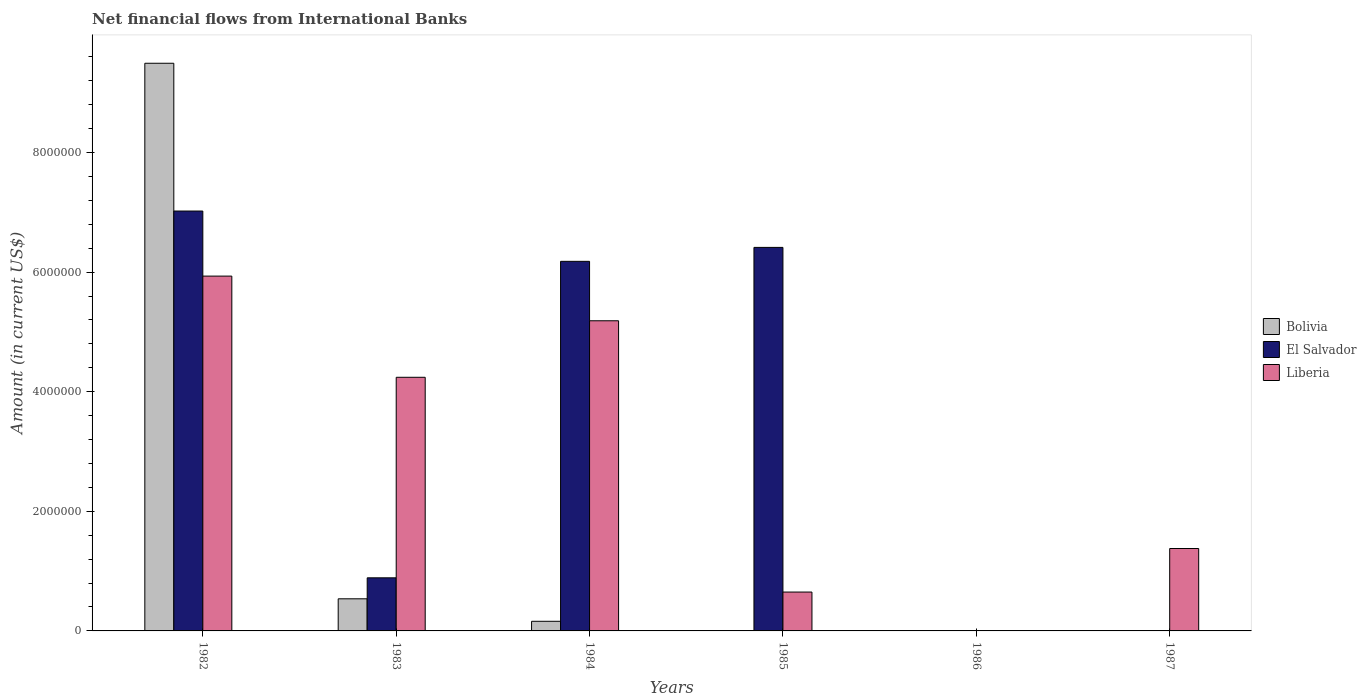How many different coloured bars are there?
Offer a terse response. 3. How many bars are there on the 3rd tick from the right?
Keep it short and to the point. 2. What is the label of the 5th group of bars from the left?
Keep it short and to the point. 1986. In how many cases, is the number of bars for a given year not equal to the number of legend labels?
Your answer should be compact. 3. What is the net financial aid flows in Bolivia in 1987?
Offer a terse response. 0. Across all years, what is the maximum net financial aid flows in El Salvador?
Your answer should be very brief. 7.02e+06. In which year was the net financial aid flows in El Salvador maximum?
Make the answer very short. 1982. What is the total net financial aid flows in Liberia in the graph?
Ensure brevity in your answer.  1.74e+07. What is the difference between the net financial aid flows in Bolivia in 1982 and that in 1983?
Offer a terse response. 8.96e+06. What is the difference between the net financial aid flows in Liberia in 1986 and the net financial aid flows in Bolivia in 1983?
Offer a very short reply. -5.37e+05. What is the average net financial aid flows in Bolivia per year?
Provide a succinct answer. 1.70e+06. In the year 1982, what is the difference between the net financial aid flows in El Salvador and net financial aid flows in Liberia?
Provide a succinct answer. 1.09e+06. What is the ratio of the net financial aid flows in Liberia in 1982 to that in 1985?
Ensure brevity in your answer.  9.13. Is the net financial aid flows in El Salvador in 1984 less than that in 1985?
Provide a succinct answer. Yes. Is the difference between the net financial aid flows in El Salvador in 1983 and 1985 greater than the difference between the net financial aid flows in Liberia in 1983 and 1985?
Provide a succinct answer. No. What is the difference between the highest and the second highest net financial aid flows in Liberia?
Provide a succinct answer. 7.47e+05. What is the difference between the highest and the lowest net financial aid flows in Bolivia?
Ensure brevity in your answer.  9.49e+06. In how many years, is the net financial aid flows in Bolivia greater than the average net financial aid flows in Bolivia taken over all years?
Provide a short and direct response. 1. Is the sum of the net financial aid flows in Bolivia in 1982 and 1984 greater than the maximum net financial aid flows in El Salvador across all years?
Keep it short and to the point. Yes. Is it the case that in every year, the sum of the net financial aid flows in Bolivia and net financial aid flows in Liberia is greater than the net financial aid flows in El Salvador?
Make the answer very short. No. Are all the bars in the graph horizontal?
Provide a short and direct response. No. Are the values on the major ticks of Y-axis written in scientific E-notation?
Keep it short and to the point. No. Does the graph contain any zero values?
Your answer should be very brief. Yes. Where does the legend appear in the graph?
Keep it short and to the point. Center right. How many legend labels are there?
Provide a short and direct response. 3. What is the title of the graph?
Make the answer very short. Net financial flows from International Banks. What is the label or title of the X-axis?
Your answer should be very brief. Years. What is the Amount (in current US$) in Bolivia in 1982?
Your answer should be very brief. 9.49e+06. What is the Amount (in current US$) of El Salvador in 1982?
Keep it short and to the point. 7.02e+06. What is the Amount (in current US$) of Liberia in 1982?
Keep it short and to the point. 5.93e+06. What is the Amount (in current US$) of Bolivia in 1983?
Your answer should be very brief. 5.37e+05. What is the Amount (in current US$) in El Salvador in 1983?
Keep it short and to the point. 8.88e+05. What is the Amount (in current US$) of Liberia in 1983?
Keep it short and to the point. 4.24e+06. What is the Amount (in current US$) in Bolivia in 1984?
Your answer should be very brief. 1.61e+05. What is the Amount (in current US$) of El Salvador in 1984?
Keep it short and to the point. 6.18e+06. What is the Amount (in current US$) of Liberia in 1984?
Give a very brief answer. 5.19e+06. What is the Amount (in current US$) of El Salvador in 1985?
Provide a short and direct response. 6.41e+06. What is the Amount (in current US$) in Liberia in 1985?
Ensure brevity in your answer.  6.50e+05. What is the Amount (in current US$) of Liberia in 1986?
Provide a succinct answer. 0. What is the Amount (in current US$) in Liberia in 1987?
Make the answer very short. 1.38e+06. Across all years, what is the maximum Amount (in current US$) in Bolivia?
Give a very brief answer. 9.49e+06. Across all years, what is the maximum Amount (in current US$) of El Salvador?
Make the answer very short. 7.02e+06. Across all years, what is the maximum Amount (in current US$) in Liberia?
Keep it short and to the point. 5.93e+06. What is the total Amount (in current US$) of Bolivia in the graph?
Keep it short and to the point. 1.02e+07. What is the total Amount (in current US$) in El Salvador in the graph?
Make the answer very short. 2.05e+07. What is the total Amount (in current US$) in Liberia in the graph?
Make the answer very short. 1.74e+07. What is the difference between the Amount (in current US$) of Bolivia in 1982 and that in 1983?
Your answer should be very brief. 8.96e+06. What is the difference between the Amount (in current US$) of El Salvador in 1982 and that in 1983?
Offer a very short reply. 6.13e+06. What is the difference between the Amount (in current US$) in Liberia in 1982 and that in 1983?
Ensure brevity in your answer.  1.69e+06. What is the difference between the Amount (in current US$) in Bolivia in 1982 and that in 1984?
Offer a very short reply. 9.33e+06. What is the difference between the Amount (in current US$) in El Salvador in 1982 and that in 1984?
Offer a very short reply. 8.41e+05. What is the difference between the Amount (in current US$) of Liberia in 1982 and that in 1984?
Provide a short and direct response. 7.47e+05. What is the difference between the Amount (in current US$) of El Salvador in 1982 and that in 1985?
Give a very brief answer. 6.08e+05. What is the difference between the Amount (in current US$) in Liberia in 1982 and that in 1985?
Your response must be concise. 5.28e+06. What is the difference between the Amount (in current US$) of Liberia in 1982 and that in 1987?
Your answer should be compact. 4.56e+06. What is the difference between the Amount (in current US$) in Bolivia in 1983 and that in 1984?
Ensure brevity in your answer.  3.76e+05. What is the difference between the Amount (in current US$) in El Salvador in 1983 and that in 1984?
Your answer should be very brief. -5.29e+06. What is the difference between the Amount (in current US$) in Liberia in 1983 and that in 1984?
Make the answer very short. -9.45e+05. What is the difference between the Amount (in current US$) of El Salvador in 1983 and that in 1985?
Give a very brief answer. -5.52e+06. What is the difference between the Amount (in current US$) in Liberia in 1983 and that in 1985?
Ensure brevity in your answer.  3.59e+06. What is the difference between the Amount (in current US$) in Liberia in 1983 and that in 1987?
Ensure brevity in your answer.  2.86e+06. What is the difference between the Amount (in current US$) in El Salvador in 1984 and that in 1985?
Ensure brevity in your answer.  -2.33e+05. What is the difference between the Amount (in current US$) in Liberia in 1984 and that in 1985?
Provide a short and direct response. 4.54e+06. What is the difference between the Amount (in current US$) of Liberia in 1984 and that in 1987?
Give a very brief answer. 3.81e+06. What is the difference between the Amount (in current US$) of Liberia in 1985 and that in 1987?
Offer a very short reply. -7.28e+05. What is the difference between the Amount (in current US$) in Bolivia in 1982 and the Amount (in current US$) in El Salvador in 1983?
Provide a succinct answer. 8.60e+06. What is the difference between the Amount (in current US$) in Bolivia in 1982 and the Amount (in current US$) in Liberia in 1983?
Provide a short and direct response. 5.25e+06. What is the difference between the Amount (in current US$) in El Salvador in 1982 and the Amount (in current US$) in Liberia in 1983?
Your answer should be compact. 2.78e+06. What is the difference between the Amount (in current US$) of Bolivia in 1982 and the Amount (in current US$) of El Salvador in 1984?
Make the answer very short. 3.31e+06. What is the difference between the Amount (in current US$) of Bolivia in 1982 and the Amount (in current US$) of Liberia in 1984?
Make the answer very short. 4.31e+06. What is the difference between the Amount (in current US$) of El Salvador in 1982 and the Amount (in current US$) of Liberia in 1984?
Offer a terse response. 1.84e+06. What is the difference between the Amount (in current US$) in Bolivia in 1982 and the Amount (in current US$) in El Salvador in 1985?
Offer a terse response. 3.08e+06. What is the difference between the Amount (in current US$) of Bolivia in 1982 and the Amount (in current US$) of Liberia in 1985?
Offer a very short reply. 8.84e+06. What is the difference between the Amount (in current US$) in El Salvador in 1982 and the Amount (in current US$) in Liberia in 1985?
Offer a very short reply. 6.37e+06. What is the difference between the Amount (in current US$) in Bolivia in 1982 and the Amount (in current US$) in Liberia in 1987?
Your response must be concise. 8.11e+06. What is the difference between the Amount (in current US$) in El Salvador in 1982 and the Amount (in current US$) in Liberia in 1987?
Your answer should be compact. 5.64e+06. What is the difference between the Amount (in current US$) in Bolivia in 1983 and the Amount (in current US$) in El Salvador in 1984?
Your answer should be compact. -5.64e+06. What is the difference between the Amount (in current US$) in Bolivia in 1983 and the Amount (in current US$) in Liberia in 1984?
Offer a very short reply. -4.65e+06. What is the difference between the Amount (in current US$) of El Salvador in 1983 and the Amount (in current US$) of Liberia in 1984?
Give a very brief answer. -4.30e+06. What is the difference between the Amount (in current US$) in Bolivia in 1983 and the Amount (in current US$) in El Salvador in 1985?
Offer a very short reply. -5.88e+06. What is the difference between the Amount (in current US$) in Bolivia in 1983 and the Amount (in current US$) in Liberia in 1985?
Provide a succinct answer. -1.13e+05. What is the difference between the Amount (in current US$) in El Salvador in 1983 and the Amount (in current US$) in Liberia in 1985?
Your answer should be compact. 2.38e+05. What is the difference between the Amount (in current US$) in Bolivia in 1983 and the Amount (in current US$) in Liberia in 1987?
Make the answer very short. -8.41e+05. What is the difference between the Amount (in current US$) of El Salvador in 1983 and the Amount (in current US$) of Liberia in 1987?
Offer a very short reply. -4.90e+05. What is the difference between the Amount (in current US$) in Bolivia in 1984 and the Amount (in current US$) in El Salvador in 1985?
Your answer should be very brief. -6.25e+06. What is the difference between the Amount (in current US$) in Bolivia in 1984 and the Amount (in current US$) in Liberia in 1985?
Offer a terse response. -4.89e+05. What is the difference between the Amount (in current US$) in El Salvador in 1984 and the Amount (in current US$) in Liberia in 1985?
Your answer should be compact. 5.53e+06. What is the difference between the Amount (in current US$) in Bolivia in 1984 and the Amount (in current US$) in Liberia in 1987?
Offer a terse response. -1.22e+06. What is the difference between the Amount (in current US$) in El Salvador in 1984 and the Amount (in current US$) in Liberia in 1987?
Ensure brevity in your answer.  4.80e+06. What is the difference between the Amount (in current US$) in El Salvador in 1985 and the Amount (in current US$) in Liberia in 1987?
Offer a terse response. 5.04e+06. What is the average Amount (in current US$) of Bolivia per year?
Your answer should be very brief. 1.70e+06. What is the average Amount (in current US$) of El Salvador per year?
Keep it short and to the point. 3.42e+06. What is the average Amount (in current US$) in Liberia per year?
Offer a very short reply. 2.90e+06. In the year 1982, what is the difference between the Amount (in current US$) of Bolivia and Amount (in current US$) of El Salvador?
Your answer should be compact. 2.47e+06. In the year 1982, what is the difference between the Amount (in current US$) of Bolivia and Amount (in current US$) of Liberia?
Ensure brevity in your answer.  3.56e+06. In the year 1982, what is the difference between the Amount (in current US$) in El Salvador and Amount (in current US$) in Liberia?
Provide a succinct answer. 1.09e+06. In the year 1983, what is the difference between the Amount (in current US$) of Bolivia and Amount (in current US$) of El Salvador?
Your response must be concise. -3.51e+05. In the year 1983, what is the difference between the Amount (in current US$) of Bolivia and Amount (in current US$) of Liberia?
Give a very brief answer. -3.70e+06. In the year 1983, what is the difference between the Amount (in current US$) in El Salvador and Amount (in current US$) in Liberia?
Give a very brief answer. -3.35e+06. In the year 1984, what is the difference between the Amount (in current US$) in Bolivia and Amount (in current US$) in El Salvador?
Make the answer very short. -6.02e+06. In the year 1984, what is the difference between the Amount (in current US$) in Bolivia and Amount (in current US$) in Liberia?
Your answer should be compact. -5.02e+06. In the year 1984, what is the difference between the Amount (in current US$) in El Salvador and Amount (in current US$) in Liberia?
Your answer should be compact. 9.94e+05. In the year 1985, what is the difference between the Amount (in current US$) in El Salvador and Amount (in current US$) in Liberia?
Your response must be concise. 5.76e+06. What is the ratio of the Amount (in current US$) of Bolivia in 1982 to that in 1983?
Offer a terse response. 17.68. What is the ratio of the Amount (in current US$) in El Salvador in 1982 to that in 1983?
Your answer should be very brief. 7.91. What is the ratio of the Amount (in current US$) in Liberia in 1982 to that in 1983?
Ensure brevity in your answer.  1.4. What is the ratio of the Amount (in current US$) in Bolivia in 1982 to that in 1984?
Keep it short and to the point. 58.96. What is the ratio of the Amount (in current US$) of El Salvador in 1982 to that in 1984?
Your answer should be very brief. 1.14. What is the ratio of the Amount (in current US$) in Liberia in 1982 to that in 1984?
Offer a terse response. 1.14. What is the ratio of the Amount (in current US$) of El Salvador in 1982 to that in 1985?
Give a very brief answer. 1.09. What is the ratio of the Amount (in current US$) in Liberia in 1982 to that in 1985?
Keep it short and to the point. 9.13. What is the ratio of the Amount (in current US$) of Liberia in 1982 to that in 1987?
Your answer should be very brief. 4.31. What is the ratio of the Amount (in current US$) in Bolivia in 1983 to that in 1984?
Give a very brief answer. 3.34. What is the ratio of the Amount (in current US$) of El Salvador in 1983 to that in 1984?
Keep it short and to the point. 0.14. What is the ratio of the Amount (in current US$) of Liberia in 1983 to that in 1984?
Your answer should be compact. 0.82. What is the ratio of the Amount (in current US$) of El Salvador in 1983 to that in 1985?
Your answer should be very brief. 0.14. What is the ratio of the Amount (in current US$) of Liberia in 1983 to that in 1985?
Give a very brief answer. 6.52. What is the ratio of the Amount (in current US$) of Liberia in 1983 to that in 1987?
Make the answer very short. 3.08. What is the ratio of the Amount (in current US$) in El Salvador in 1984 to that in 1985?
Make the answer very short. 0.96. What is the ratio of the Amount (in current US$) in Liberia in 1984 to that in 1985?
Ensure brevity in your answer.  7.98. What is the ratio of the Amount (in current US$) in Liberia in 1984 to that in 1987?
Your response must be concise. 3.76. What is the ratio of the Amount (in current US$) of Liberia in 1985 to that in 1987?
Provide a short and direct response. 0.47. What is the difference between the highest and the second highest Amount (in current US$) in Bolivia?
Offer a terse response. 8.96e+06. What is the difference between the highest and the second highest Amount (in current US$) in El Salvador?
Provide a short and direct response. 6.08e+05. What is the difference between the highest and the second highest Amount (in current US$) of Liberia?
Offer a very short reply. 7.47e+05. What is the difference between the highest and the lowest Amount (in current US$) of Bolivia?
Your response must be concise. 9.49e+06. What is the difference between the highest and the lowest Amount (in current US$) in El Salvador?
Make the answer very short. 7.02e+06. What is the difference between the highest and the lowest Amount (in current US$) of Liberia?
Keep it short and to the point. 5.93e+06. 